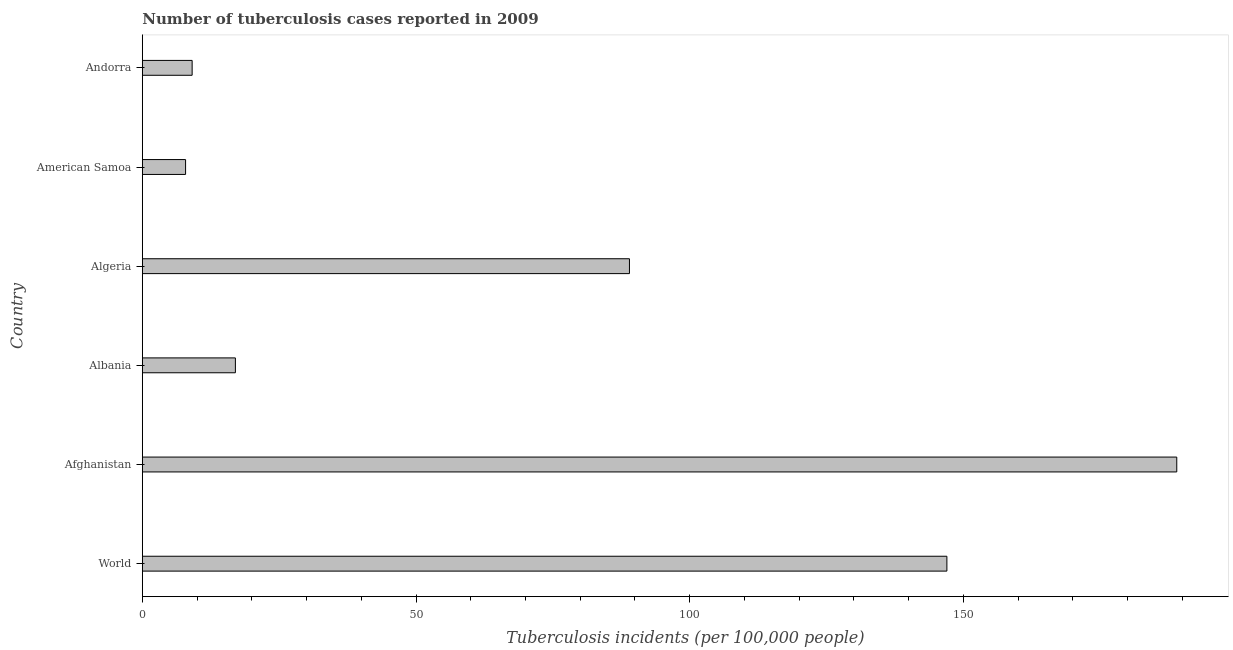What is the title of the graph?
Your answer should be compact. Number of tuberculosis cases reported in 2009. What is the label or title of the X-axis?
Provide a short and direct response. Tuberculosis incidents (per 100,0 people). What is the number of tuberculosis incidents in Algeria?
Provide a short and direct response. 89. Across all countries, what is the maximum number of tuberculosis incidents?
Offer a very short reply. 189. Across all countries, what is the minimum number of tuberculosis incidents?
Ensure brevity in your answer.  7.9. In which country was the number of tuberculosis incidents maximum?
Keep it short and to the point. Afghanistan. In which country was the number of tuberculosis incidents minimum?
Make the answer very short. American Samoa. What is the sum of the number of tuberculosis incidents?
Make the answer very short. 459. What is the difference between the number of tuberculosis incidents in Afghanistan and World?
Provide a short and direct response. 42. What is the average number of tuberculosis incidents per country?
Your answer should be compact. 76.5. In how many countries, is the number of tuberculosis incidents greater than 20 ?
Your answer should be compact. 3. What is the ratio of the number of tuberculosis incidents in Algeria to that in Andorra?
Your answer should be very brief. 9.78. Is the difference between the number of tuberculosis incidents in Afghanistan and Albania greater than the difference between any two countries?
Keep it short and to the point. No. What is the difference between the highest and the second highest number of tuberculosis incidents?
Make the answer very short. 42. Is the sum of the number of tuberculosis incidents in Andorra and World greater than the maximum number of tuberculosis incidents across all countries?
Your answer should be compact. No. What is the difference between the highest and the lowest number of tuberculosis incidents?
Keep it short and to the point. 181.1. In how many countries, is the number of tuberculosis incidents greater than the average number of tuberculosis incidents taken over all countries?
Give a very brief answer. 3. How many bars are there?
Give a very brief answer. 6. Are all the bars in the graph horizontal?
Offer a very short reply. Yes. How many countries are there in the graph?
Make the answer very short. 6. What is the Tuberculosis incidents (per 100,000 people) of World?
Offer a very short reply. 147. What is the Tuberculosis incidents (per 100,000 people) of Afghanistan?
Give a very brief answer. 189. What is the Tuberculosis incidents (per 100,000 people) in Albania?
Make the answer very short. 17. What is the Tuberculosis incidents (per 100,000 people) in Algeria?
Ensure brevity in your answer.  89. What is the Tuberculosis incidents (per 100,000 people) in American Samoa?
Keep it short and to the point. 7.9. What is the difference between the Tuberculosis incidents (per 100,000 people) in World and Afghanistan?
Provide a short and direct response. -42. What is the difference between the Tuberculosis incidents (per 100,000 people) in World and Albania?
Make the answer very short. 130. What is the difference between the Tuberculosis incidents (per 100,000 people) in World and American Samoa?
Provide a short and direct response. 139.1. What is the difference between the Tuberculosis incidents (per 100,000 people) in World and Andorra?
Provide a short and direct response. 137.9. What is the difference between the Tuberculosis incidents (per 100,000 people) in Afghanistan and Albania?
Make the answer very short. 172. What is the difference between the Tuberculosis incidents (per 100,000 people) in Afghanistan and American Samoa?
Keep it short and to the point. 181.1. What is the difference between the Tuberculosis incidents (per 100,000 people) in Afghanistan and Andorra?
Provide a succinct answer. 179.9. What is the difference between the Tuberculosis incidents (per 100,000 people) in Albania and Algeria?
Your response must be concise. -72. What is the difference between the Tuberculosis incidents (per 100,000 people) in Algeria and American Samoa?
Your response must be concise. 81.1. What is the difference between the Tuberculosis incidents (per 100,000 people) in Algeria and Andorra?
Provide a short and direct response. 79.9. What is the difference between the Tuberculosis incidents (per 100,000 people) in American Samoa and Andorra?
Give a very brief answer. -1.2. What is the ratio of the Tuberculosis incidents (per 100,000 people) in World to that in Afghanistan?
Your answer should be very brief. 0.78. What is the ratio of the Tuberculosis incidents (per 100,000 people) in World to that in Albania?
Give a very brief answer. 8.65. What is the ratio of the Tuberculosis incidents (per 100,000 people) in World to that in Algeria?
Provide a short and direct response. 1.65. What is the ratio of the Tuberculosis incidents (per 100,000 people) in World to that in American Samoa?
Your answer should be compact. 18.61. What is the ratio of the Tuberculosis incidents (per 100,000 people) in World to that in Andorra?
Ensure brevity in your answer.  16.15. What is the ratio of the Tuberculosis incidents (per 100,000 people) in Afghanistan to that in Albania?
Give a very brief answer. 11.12. What is the ratio of the Tuberculosis incidents (per 100,000 people) in Afghanistan to that in Algeria?
Your answer should be compact. 2.12. What is the ratio of the Tuberculosis incidents (per 100,000 people) in Afghanistan to that in American Samoa?
Provide a succinct answer. 23.92. What is the ratio of the Tuberculosis incidents (per 100,000 people) in Afghanistan to that in Andorra?
Keep it short and to the point. 20.77. What is the ratio of the Tuberculosis incidents (per 100,000 people) in Albania to that in Algeria?
Keep it short and to the point. 0.19. What is the ratio of the Tuberculosis incidents (per 100,000 people) in Albania to that in American Samoa?
Provide a short and direct response. 2.15. What is the ratio of the Tuberculosis incidents (per 100,000 people) in Albania to that in Andorra?
Give a very brief answer. 1.87. What is the ratio of the Tuberculosis incidents (per 100,000 people) in Algeria to that in American Samoa?
Make the answer very short. 11.27. What is the ratio of the Tuberculosis incidents (per 100,000 people) in Algeria to that in Andorra?
Your response must be concise. 9.78. What is the ratio of the Tuberculosis incidents (per 100,000 people) in American Samoa to that in Andorra?
Offer a very short reply. 0.87. 